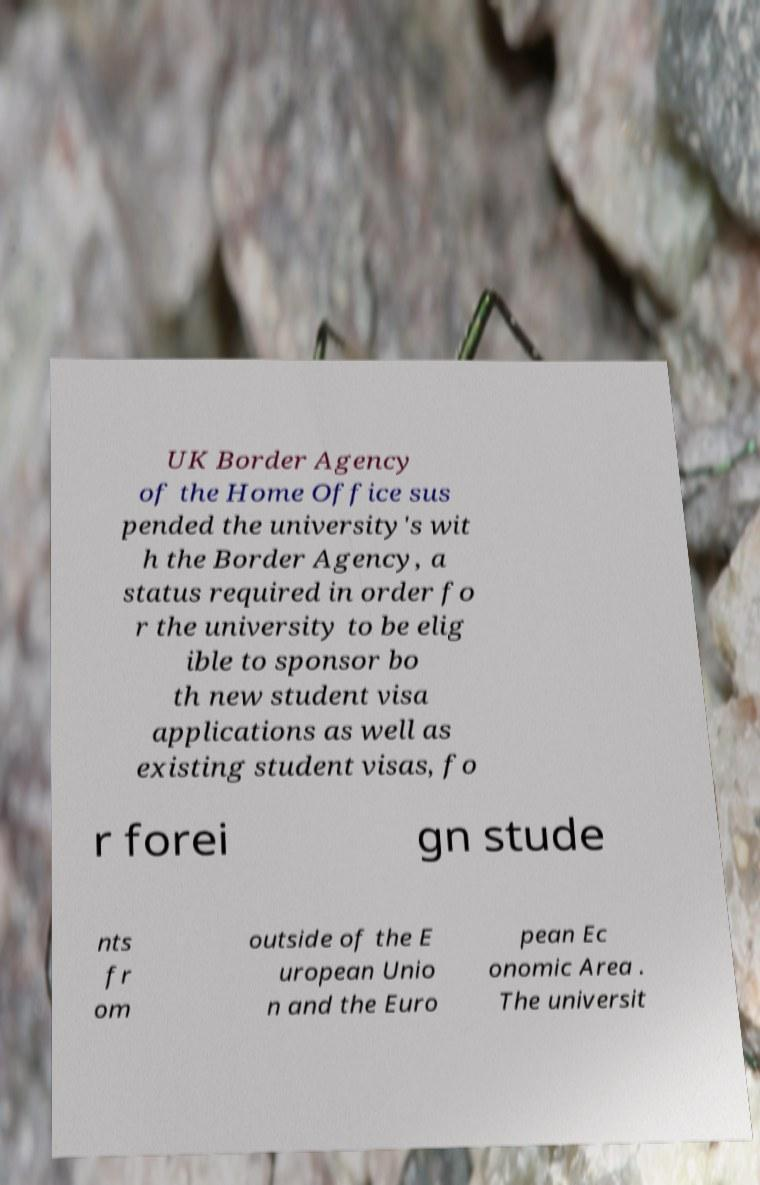Please identify and transcribe the text found in this image. UK Border Agency of the Home Office sus pended the university's wit h the Border Agency, a status required in order fo r the university to be elig ible to sponsor bo th new student visa applications as well as existing student visas, fo r forei gn stude nts fr om outside of the E uropean Unio n and the Euro pean Ec onomic Area . The universit 